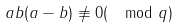Convert formula to latex. <formula><loc_0><loc_0><loc_500><loc_500>a b ( a - b ) \not \equiv 0 ( \mod q )</formula> 